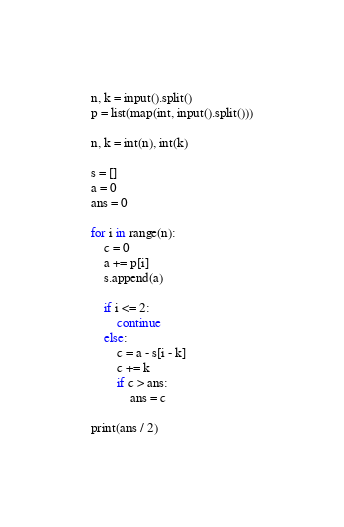<code> <loc_0><loc_0><loc_500><loc_500><_Python_>
n, k = input().split()
p = list(map(int, input().split()))

n, k = int(n), int(k)

s = []
a = 0
ans = 0

for i in range(n):
    c = 0
    a += p[i]
    s.append(a)
    
    if i <= 2:
        continue
    else:
        c = a - s[i - k]
        c += k
        if c > ans:
            ans = c

print(ans / 2)
</code> 